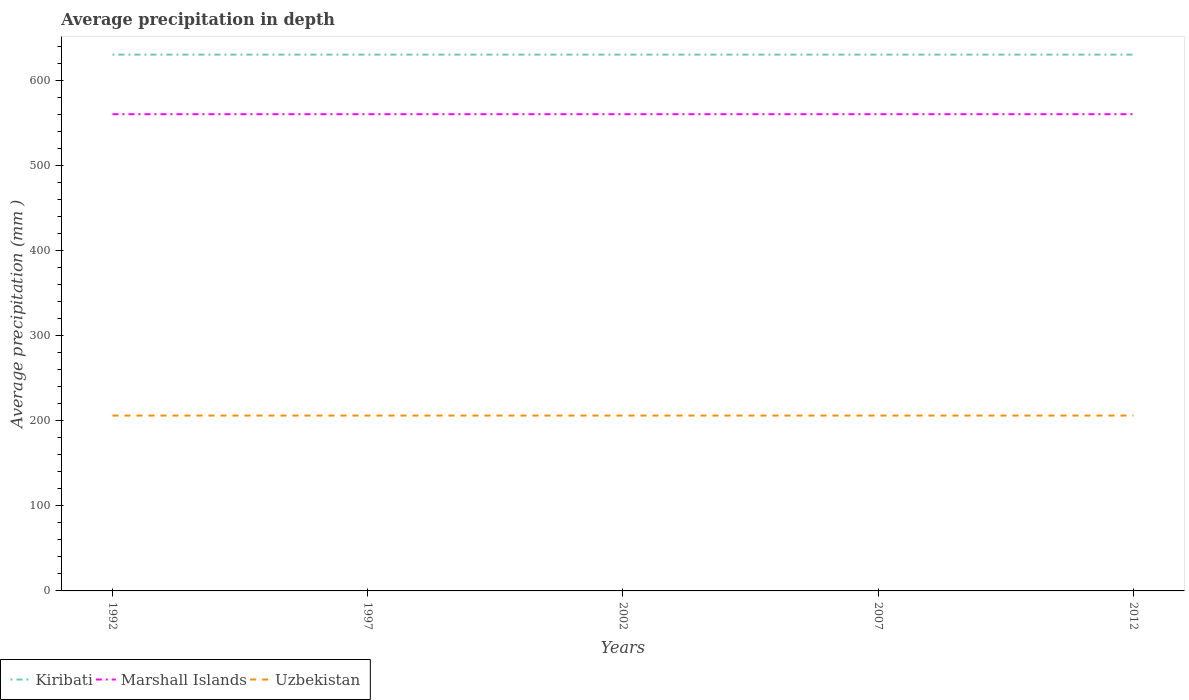Is the number of lines equal to the number of legend labels?
Make the answer very short. Yes. Across all years, what is the maximum average precipitation in Kiribati?
Offer a terse response. 630. In which year was the average precipitation in Kiribati maximum?
Give a very brief answer. 1992. Is the average precipitation in Uzbekistan strictly greater than the average precipitation in Kiribati over the years?
Your answer should be very brief. Yes. How many years are there in the graph?
Keep it short and to the point. 5. What is the difference between two consecutive major ticks on the Y-axis?
Your answer should be very brief. 100. Does the graph contain grids?
Your answer should be very brief. No. What is the title of the graph?
Provide a succinct answer. Average precipitation in depth. What is the label or title of the X-axis?
Provide a succinct answer. Years. What is the label or title of the Y-axis?
Ensure brevity in your answer.  Average precipitation (mm ). What is the Average precipitation (mm ) of Kiribati in 1992?
Provide a succinct answer. 630. What is the Average precipitation (mm ) of Marshall Islands in 1992?
Offer a terse response. 560. What is the Average precipitation (mm ) in Uzbekistan in 1992?
Provide a short and direct response. 206. What is the Average precipitation (mm ) of Kiribati in 1997?
Give a very brief answer. 630. What is the Average precipitation (mm ) of Marshall Islands in 1997?
Provide a short and direct response. 560. What is the Average precipitation (mm ) in Uzbekistan in 1997?
Give a very brief answer. 206. What is the Average precipitation (mm ) in Kiribati in 2002?
Your answer should be very brief. 630. What is the Average precipitation (mm ) in Marshall Islands in 2002?
Your answer should be very brief. 560. What is the Average precipitation (mm ) in Uzbekistan in 2002?
Give a very brief answer. 206. What is the Average precipitation (mm ) of Kiribati in 2007?
Keep it short and to the point. 630. What is the Average precipitation (mm ) in Marshall Islands in 2007?
Keep it short and to the point. 560. What is the Average precipitation (mm ) in Uzbekistan in 2007?
Ensure brevity in your answer.  206. What is the Average precipitation (mm ) in Kiribati in 2012?
Keep it short and to the point. 630. What is the Average precipitation (mm ) in Marshall Islands in 2012?
Provide a short and direct response. 560. What is the Average precipitation (mm ) in Uzbekistan in 2012?
Ensure brevity in your answer.  206. Across all years, what is the maximum Average precipitation (mm ) of Kiribati?
Your response must be concise. 630. Across all years, what is the maximum Average precipitation (mm ) of Marshall Islands?
Provide a succinct answer. 560. Across all years, what is the maximum Average precipitation (mm ) in Uzbekistan?
Make the answer very short. 206. Across all years, what is the minimum Average precipitation (mm ) of Kiribati?
Give a very brief answer. 630. Across all years, what is the minimum Average precipitation (mm ) in Marshall Islands?
Your answer should be very brief. 560. Across all years, what is the minimum Average precipitation (mm ) in Uzbekistan?
Provide a short and direct response. 206. What is the total Average precipitation (mm ) in Kiribati in the graph?
Keep it short and to the point. 3150. What is the total Average precipitation (mm ) of Marshall Islands in the graph?
Ensure brevity in your answer.  2800. What is the total Average precipitation (mm ) of Uzbekistan in the graph?
Your answer should be compact. 1030. What is the difference between the Average precipitation (mm ) of Kiribati in 1992 and that in 1997?
Offer a very short reply. 0. What is the difference between the Average precipitation (mm ) of Marshall Islands in 1992 and that in 2012?
Offer a very short reply. 0. What is the difference between the Average precipitation (mm ) of Kiribati in 1997 and that in 2002?
Your answer should be compact. 0. What is the difference between the Average precipitation (mm ) in Marshall Islands in 1997 and that in 2002?
Give a very brief answer. 0. What is the difference between the Average precipitation (mm ) in Marshall Islands in 1997 and that in 2007?
Provide a succinct answer. 0. What is the difference between the Average precipitation (mm ) in Uzbekistan in 1997 and that in 2007?
Offer a terse response. 0. What is the difference between the Average precipitation (mm ) in Kiribati in 2002 and that in 2007?
Provide a succinct answer. 0. What is the difference between the Average precipitation (mm ) in Marshall Islands in 2002 and that in 2007?
Ensure brevity in your answer.  0. What is the difference between the Average precipitation (mm ) of Uzbekistan in 2007 and that in 2012?
Ensure brevity in your answer.  0. What is the difference between the Average precipitation (mm ) in Kiribati in 1992 and the Average precipitation (mm ) in Uzbekistan in 1997?
Ensure brevity in your answer.  424. What is the difference between the Average precipitation (mm ) of Marshall Islands in 1992 and the Average precipitation (mm ) of Uzbekistan in 1997?
Provide a short and direct response. 354. What is the difference between the Average precipitation (mm ) of Kiribati in 1992 and the Average precipitation (mm ) of Marshall Islands in 2002?
Your response must be concise. 70. What is the difference between the Average precipitation (mm ) in Kiribati in 1992 and the Average precipitation (mm ) in Uzbekistan in 2002?
Ensure brevity in your answer.  424. What is the difference between the Average precipitation (mm ) in Marshall Islands in 1992 and the Average precipitation (mm ) in Uzbekistan in 2002?
Your response must be concise. 354. What is the difference between the Average precipitation (mm ) in Kiribati in 1992 and the Average precipitation (mm ) in Uzbekistan in 2007?
Your answer should be compact. 424. What is the difference between the Average precipitation (mm ) of Marshall Islands in 1992 and the Average precipitation (mm ) of Uzbekistan in 2007?
Make the answer very short. 354. What is the difference between the Average precipitation (mm ) of Kiribati in 1992 and the Average precipitation (mm ) of Uzbekistan in 2012?
Keep it short and to the point. 424. What is the difference between the Average precipitation (mm ) in Marshall Islands in 1992 and the Average precipitation (mm ) in Uzbekistan in 2012?
Your response must be concise. 354. What is the difference between the Average precipitation (mm ) of Kiribati in 1997 and the Average precipitation (mm ) of Uzbekistan in 2002?
Provide a short and direct response. 424. What is the difference between the Average precipitation (mm ) in Marshall Islands in 1997 and the Average precipitation (mm ) in Uzbekistan in 2002?
Your answer should be compact. 354. What is the difference between the Average precipitation (mm ) in Kiribati in 1997 and the Average precipitation (mm ) in Marshall Islands in 2007?
Ensure brevity in your answer.  70. What is the difference between the Average precipitation (mm ) in Kiribati in 1997 and the Average precipitation (mm ) in Uzbekistan in 2007?
Make the answer very short. 424. What is the difference between the Average precipitation (mm ) of Marshall Islands in 1997 and the Average precipitation (mm ) of Uzbekistan in 2007?
Your answer should be compact. 354. What is the difference between the Average precipitation (mm ) in Kiribati in 1997 and the Average precipitation (mm ) in Marshall Islands in 2012?
Your answer should be very brief. 70. What is the difference between the Average precipitation (mm ) of Kiribati in 1997 and the Average precipitation (mm ) of Uzbekistan in 2012?
Give a very brief answer. 424. What is the difference between the Average precipitation (mm ) in Marshall Islands in 1997 and the Average precipitation (mm ) in Uzbekistan in 2012?
Keep it short and to the point. 354. What is the difference between the Average precipitation (mm ) of Kiribati in 2002 and the Average precipitation (mm ) of Uzbekistan in 2007?
Keep it short and to the point. 424. What is the difference between the Average precipitation (mm ) of Marshall Islands in 2002 and the Average precipitation (mm ) of Uzbekistan in 2007?
Ensure brevity in your answer.  354. What is the difference between the Average precipitation (mm ) of Kiribati in 2002 and the Average precipitation (mm ) of Marshall Islands in 2012?
Provide a short and direct response. 70. What is the difference between the Average precipitation (mm ) in Kiribati in 2002 and the Average precipitation (mm ) in Uzbekistan in 2012?
Provide a short and direct response. 424. What is the difference between the Average precipitation (mm ) in Marshall Islands in 2002 and the Average precipitation (mm ) in Uzbekistan in 2012?
Provide a succinct answer. 354. What is the difference between the Average precipitation (mm ) in Kiribati in 2007 and the Average precipitation (mm ) in Marshall Islands in 2012?
Provide a short and direct response. 70. What is the difference between the Average precipitation (mm ) in Kiribati in 2007 and the Average precipitation (mm ) in Uzbekistan in 2012?
Offer a very short reply. 424. What is the difference between the Average precipitation (mm ) in Marshall Islands in 2007 and the Average precipitation (mm ) in Uzbekistan in 2012?
Your response must be concise. 354. What is the average Average precipitation (mm ) in Kiribati per year?
Your response must be concise. 630. What is the average Average precipitation (mm ) of Marshall Islands per year?
Your answer should be very brief. 560. What is the average Average precipitation (mm ) in Uzbekistan per year?
Your response must be concise. 206. In the year 1992, what is the difference between the Average precipitation (mm ) of Kiribati and Average precipitation (mm ) of Uzbekistan?
Provide a short and direct response. 424. In the year 1992, what is the difference between the Average precipitation (mm ) of Marshall Islands and Average precipitation (mm ) of Uzbekistan?
Your answer should be compact. 354. In the year 1997, what is the difference between the Average precipitation (mm ) in Kiribati and Average precipitation (mm ) in Uzbekistan?
Give a very brief answer. 424. In the year 1997, what is the difference between the Average precipitation (mm ) in Marshall Islands and Average precipitation (mm ) in Uzbekistan?
Your answer should be very brief. 354. In the year 2002, what is the difference between the Average precipitation (mm ) of Kiribati and Average precipitation (mm ) of Uzbekistan?
Your answer should be compact. 424. In the year 2002, what is the difference between the Average precipitation (mm ) of Marshall Islands and Average precipitation (mm ) of Uzbekistan?
Provide a short and direct response. 354. In the year 2007, what is the difference between the Average precipitation (mm ) in Kiribati and Average precipitation (mm ) in Uzbekistan?
Keep it short and to the point. 424. In the year 2007, what is the difference between the Average precipitation (mm ) in Marshall Islands and Average precipitation (mm ) in Uzbekistan?
Offer a very short reply. 354. In the year 2012, what is the difference between the Average precipitation (mm ) in Kiribati and Average precipitation (mm ) in Uzbekistan?
Your answer should be compact. 424. In the year 2012, what is the difference between the Average precipitation (mm ) of Marshall Islands and Average precipitation (mm ) of Uzbekistan?
Your answer should be very brief. 354. What is the ratio of the Average precipitation (mm ) of Kiribati in 1992 to that in 1997?
Keep it short and to the point. 1. What is the ratio of the Average precipitation (mm ) in Marshall Islands in 1992 to that in 2002?
Your answer should be very brief. 1. What is the ratio of the Average precipitation (mm ) of Uzbekistan in 1992 to that in 2002?
Give a very brief answer. 1. What is the ratio of the Average precipitation (mm ) of Kiribati in 1992 to that in 2007?
Provide a short and direct response. 1. What is the ratio of the Average precipitation (mm ) of Marshall Islands in 1992 to that in 2007?
Your answer should be compact. 1. What is the ratio of the Average precipitation (mm ) in Uzbekistan in 1992 to that in 2007?
Your answer should be compact. 1. What is the ratio of the Average precipitation (mm ) in Kiribati in 1992 to that in 2012?
Offer a terse response. 1. What is the ratio of the Average precipitation (mm ) in Uzbekistan in 1992 to that in 2012?
Keep it short and to the point. 1. What is the ratio of the Average precipitation (mm ) in Kiribati in 1997 to that in 2002?
Your answer should be very brief. 1. What is the ratio of the Average precipitation (mm ) of Marshall Islands in 1997 to that in 2002?
Your answer should be compact. 1. What is the ratio of the Average precipitation (mm ) of Uzbekistan in 1997 to that in 2002?
Your response must be concise. 1. What is the ratio of the Average precipitation (mm ) in Marshall Islands in 1997 to that in 2007?
Provide a short and direct response. 1. What is the ratio of the Average precipitation (mm ) of Kiribati in 1997 to that in 2012?
Your answer should be compact. 1. What is the ratio of the Average precipitation (mm ) in Marshall Islands in 2002 to that in 2012?
Make the answer very short. 1. What is the ratio of the Average precipitation (mm ) of Uzbekistan in 2002 to that in 2012?
Make the answer very short. 1. What is the ratio of the Average precipitation (mm ) in Marshall Islands in 2007 to that in 2012?
Offer a very short reply. 1. What is the difference between the highest and the second highest Average precipitation (mm ) of Uzbekistan?
Your answer should be very brief. 0. 